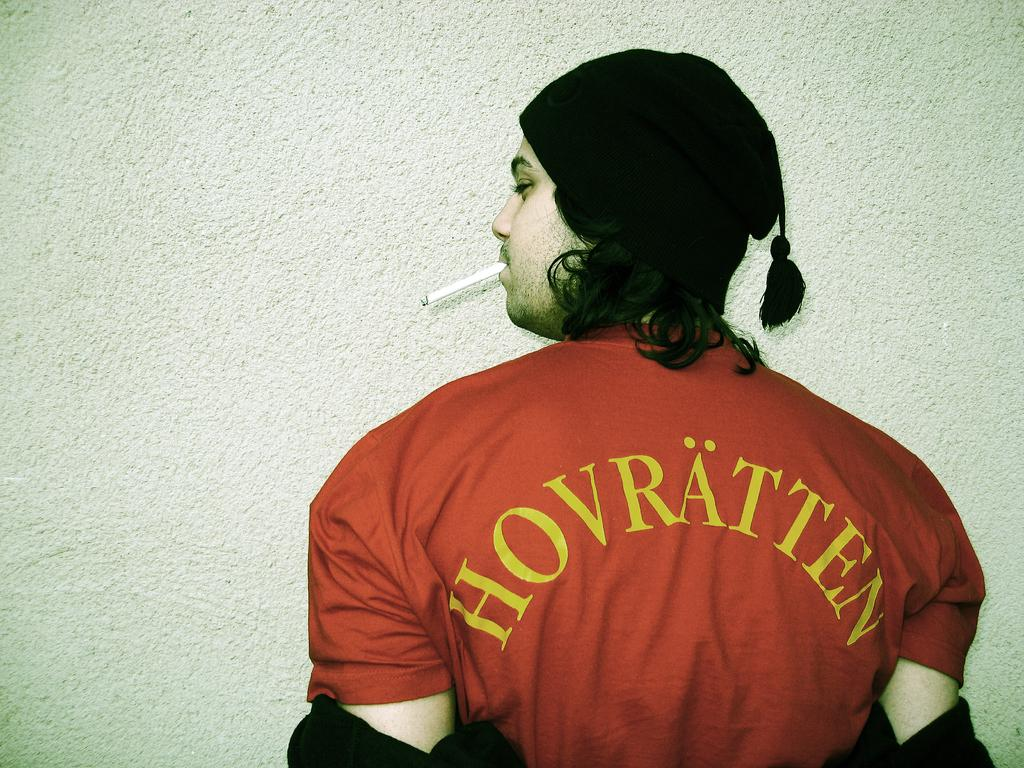<image>
Present a compact description of the photo's key features. A man wearing a red shirt with the word Hovratten on the back, has a cigarette hanging out of his mouth. 